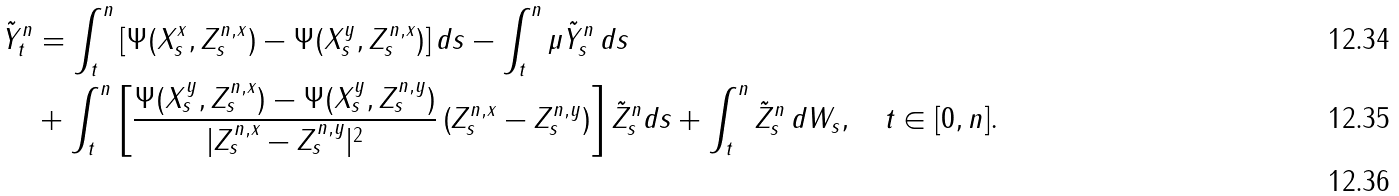Convert formula to latex. <formula><loc_0><loc_0><loc_500><loc_500>\tilde { Y } ^ { n } _ { t } & = \int _ { t } ^ { n } \left [ \Psi ( X _ { s } ^ { x } , Z _ { s } ^ { n , x } ) - \Psi ( X _ { s } ^ { y } , Z _ { s } ^ { n , x } ) \right ] d s - \int _ { t } ^ { n } \mu \tilde { Y } ^ { n } _ { s } \, d s \\ & + \int _ { t } ^ { n } \left [ \frac { \Psi ( X _ { s } ^ { y } , Z _ { s } ^ { n , x } ) - \Psi ( X _ { s } ^ { y } , Z _ { s } ^ { n , y } ) } { | Z _ { s } ^ { n , x } - Z _ { s } ^ { n , y } | ^ { 2 } } \left ( Z _ { s } ^ { n , x } - Z _ { s } ^ { n , y } \right ) \right ] \tilde { Z } ^ { n } _ { s } d s + \int _ { t } ^ { n } \tilde { Z } ^ { n } _ { s } \, d W _ { s } , \quad t \in [ 0 , n ] . \\</formula> 